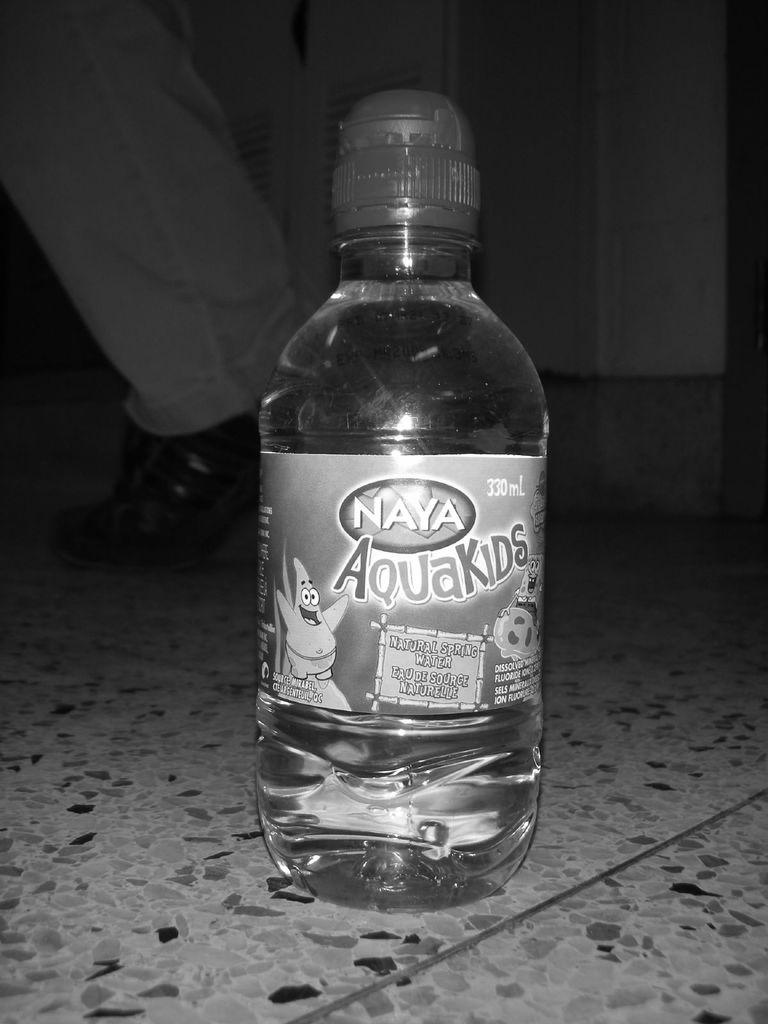<image>
Present a compact description of the photo's key features. A bottle of Naya AquaKids has Patrick on the label. 